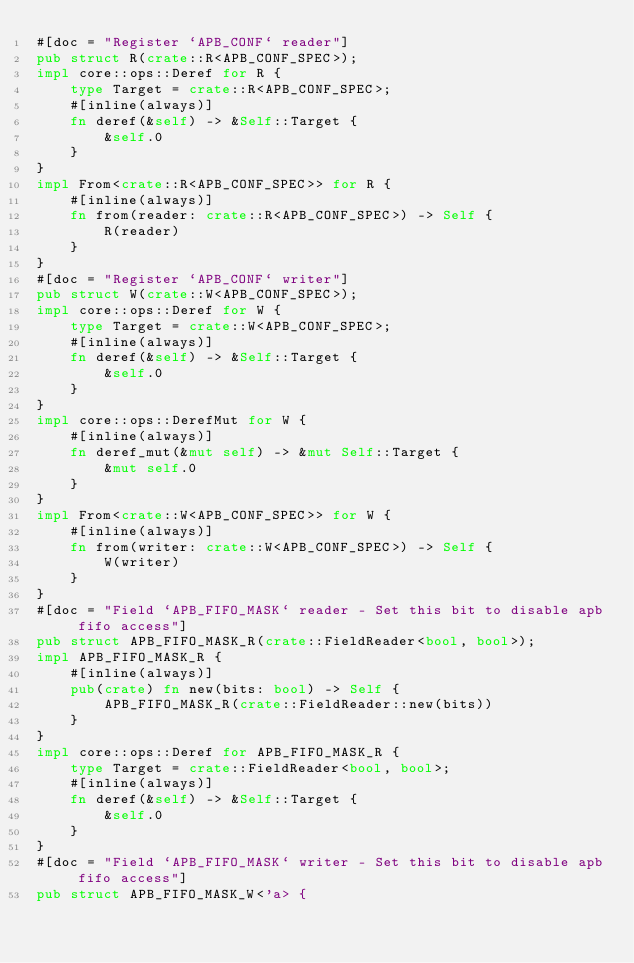<code> <loc_0><loc_0><loc_500><loc_500><_Rust_>#[doc = "Register `APB_CONF` reader"]
pub struct R(crate::R<APB_CONF_SPEC>);
impl core::ops::Deref for R {
    type Target = crate::R<APB_CONF_SPEC>;
    #[inline(always)]
    fn deref(&self) -> &Self::Target {
        &self.0
    }
}
impl From<crate::R<APB_CONF_SPEC>> for R {
    #[inline(always)]
    fn from(reader: crate::R<APB_CONF_SPEC>) -> Self {
        R(reader)
    }
}
#[doc = "Register `APB_CONF` writer"]
pub struct W(crate::W<APB_CONF_SPEC>);
impl core::ops::Deref for W {
    type Target = crate::W<APB_CONF_SPEC>;
    #[inline(always)]
    fn deref(&self) -> &Self::Target {
        &self.0
    }
}
impl core::ops::DerefMut for W {
    #[inline(always)]
    fn deref_mut(&mut self) -> &mut Self::Target {
        &mut self.0
    }
}
impl From<crate::W<APB_CONF_SPEC>> for W {
    #[inline(always)]
    fn from(writer: crate::W<APB_CONF_SPEC>) -> Self {
        W(writer)
    }
}
#[doc = "Field `APB_FIFO_MASK` reader - Set this bit to disable apb fifo access"]
pub struct APB_FIFO_MASK_R(crate::FieldReader<bool, bool>);
impl APB_FIFO_MASK_R {
    #[inline(always)]
    pub(crate) fn new(bits: bool) -> Self {
        APB_FIFO_MASK_R(crate::FieldReader::new(bits))
    }
}
impl core::ops::Deref for APB_FIFO_MASK_R {
    type Target = crate::FieldReader<bool, bool>;
    #[inline(always)]
    fn deref(&self) -> &Self::Target {
        &self.0
    }
}
#[doc = "Field `APB_FIFO_MASK` writer - Set this bit to disable apb fifo access"]
pub struct APB_FIFO_MASK_W<'a> {</code> 